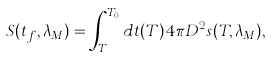<formula> <loc_0><loc_0><loc_500><loc_500>S ( t _ { f } , \lambda _ { M } ) = \int _ { T _ { A H } } ^ { T _ { 0 } } d t ( T ) 4 \pi D ^ { 2 } s ( T , \lambda _ { M } ) ,</formula> 